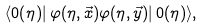<formula> <loc_0><loc_0><loc_500><loc_500>\langle 0 ( \eta ) | \, \varphi ( \eta , \vec { x } ) \varphi ( \eta , \vec { y } ) | \, 0 ( \eta ) \rangle ,</formula> 